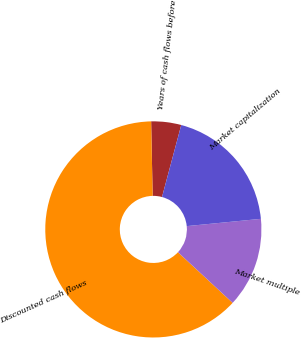Convert chart. <chart><loc_0><loc_0><loc_500><loc_500><pie_chart><fcel>Years of cash flows before<fcel>Discounted cash flows<fcel>Market multiple<fcel>Market capitalization<nl><fcel>4.48%<fcel>62.78%<fcel>13.45%<fcel>19.28%<nl></chart> 